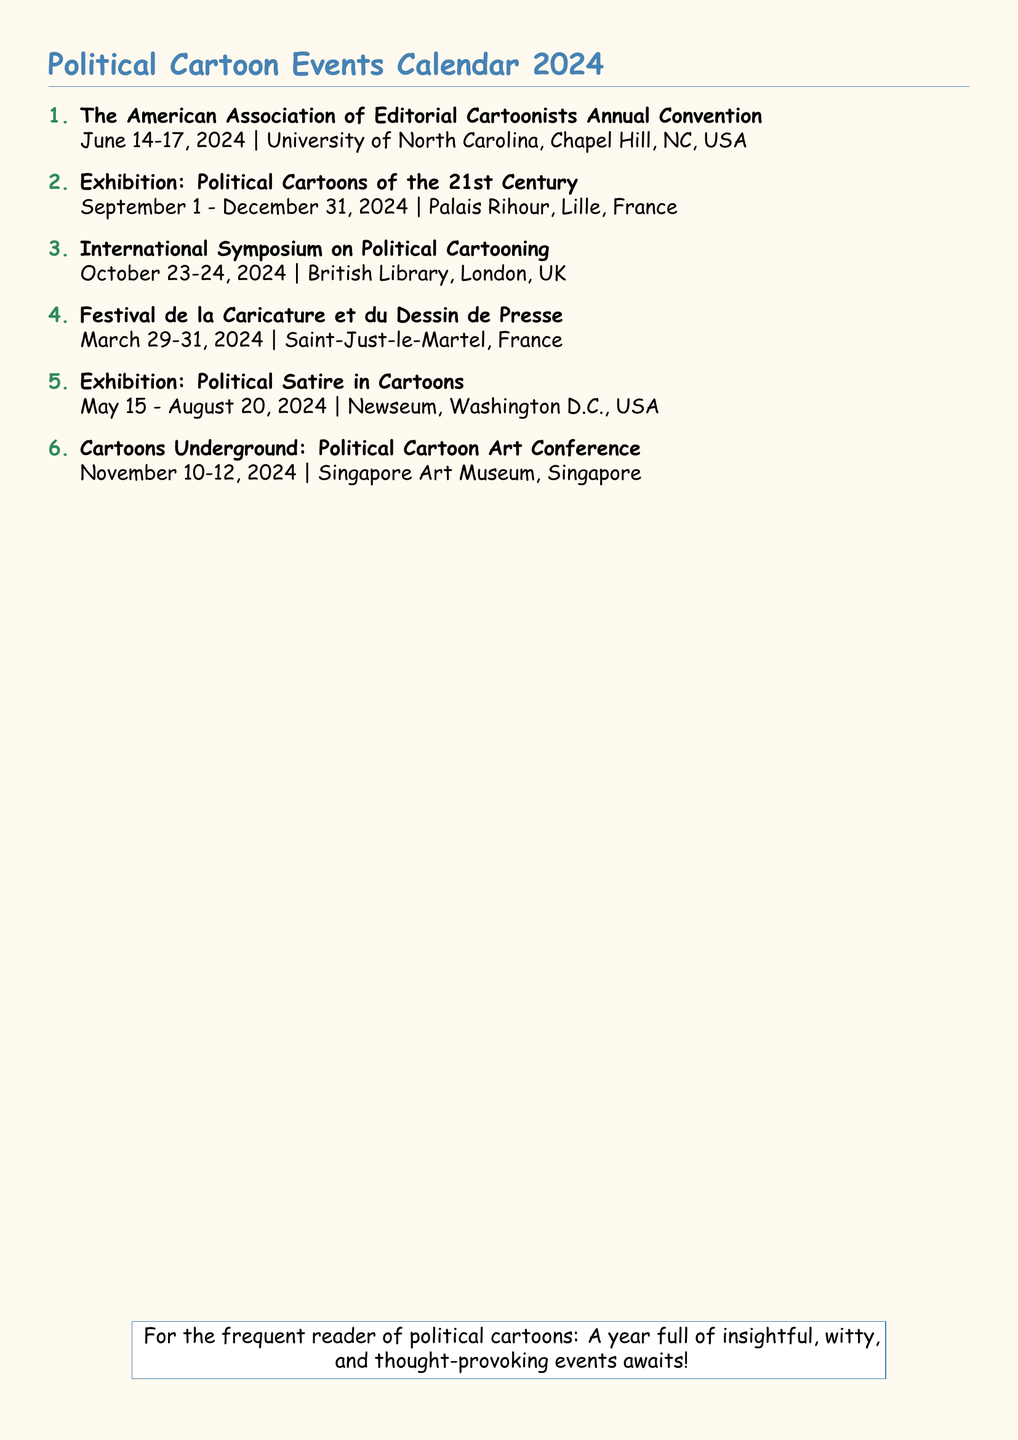What is the date of the American Association of Editorial Cartoonists Annual Convention? The date is mentioned directly in the document as June 14-17, 2024.
Answer: June 14-17, 2024 Where is the Exhibition: Political Cartoons of the 21st Century being held? The venue for the exhibition is stated in the document as Palais Rihour, Lille, France.
Answer: Palais Rihour, Lille, France How many days does the Festival de la Caricature et du Dessin de Presse last? The event lasts from March 29 to March 31, 2024, which is three days.
Answer: 3 days What is the location of the International Symposium on Political Cartooning? The document specifies the location as British Library, London, UK.
Answer: British Library, London, UK Which exhibition runs from May 15 to August 20, 2024? The exhibition titled Political Satire in Cartoons is indicated to run during those dates in the document.
Answer: Political Satire in Cartoons What is the duration of the Exhibition: Political Cartoons of the 21st Century? The exhibition is scheduled from September 1 to December 31, 2024, indicating a duration of four months.
Answer: 4 months What event occurs last in the calendar year? Cartoons Underground: Political Cartoon Art Conference is noted as occurring on November 10-12, 2024, making it the last event in that year.
Answer: Cartoons Underground: Political Cartoon Art Conference Which organization is associated with the annual convention in June? The organization mentioned is the American Association of Editorial Cartoonists, as per the title in the document.
Answer: American Association of Editorial Cartoonists 